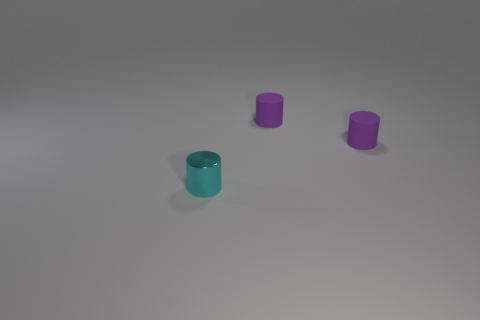Subtract all purple rubber cylinders. How many cylinders are left? 1 Subtract all brown cubes. How many purple cylinders are left? 2 Subtract 1 cylinders. How many cylinders are left? 2 Add 2 small purple rubber cylinders. How many objects exist? 5 Subtract all brown cylinders. Subtract all green balls. How many cylinders are left? 3 Add 3 cylinders. How many cylinders are left? 6 Add 1 small cyan objects. How many small cyan objects exist? 2 Subtract 0 red cylinders. How many objects are left? 3 Subtract all cyan objects. Subtract all brown rubber things. How many objects are left? 2 